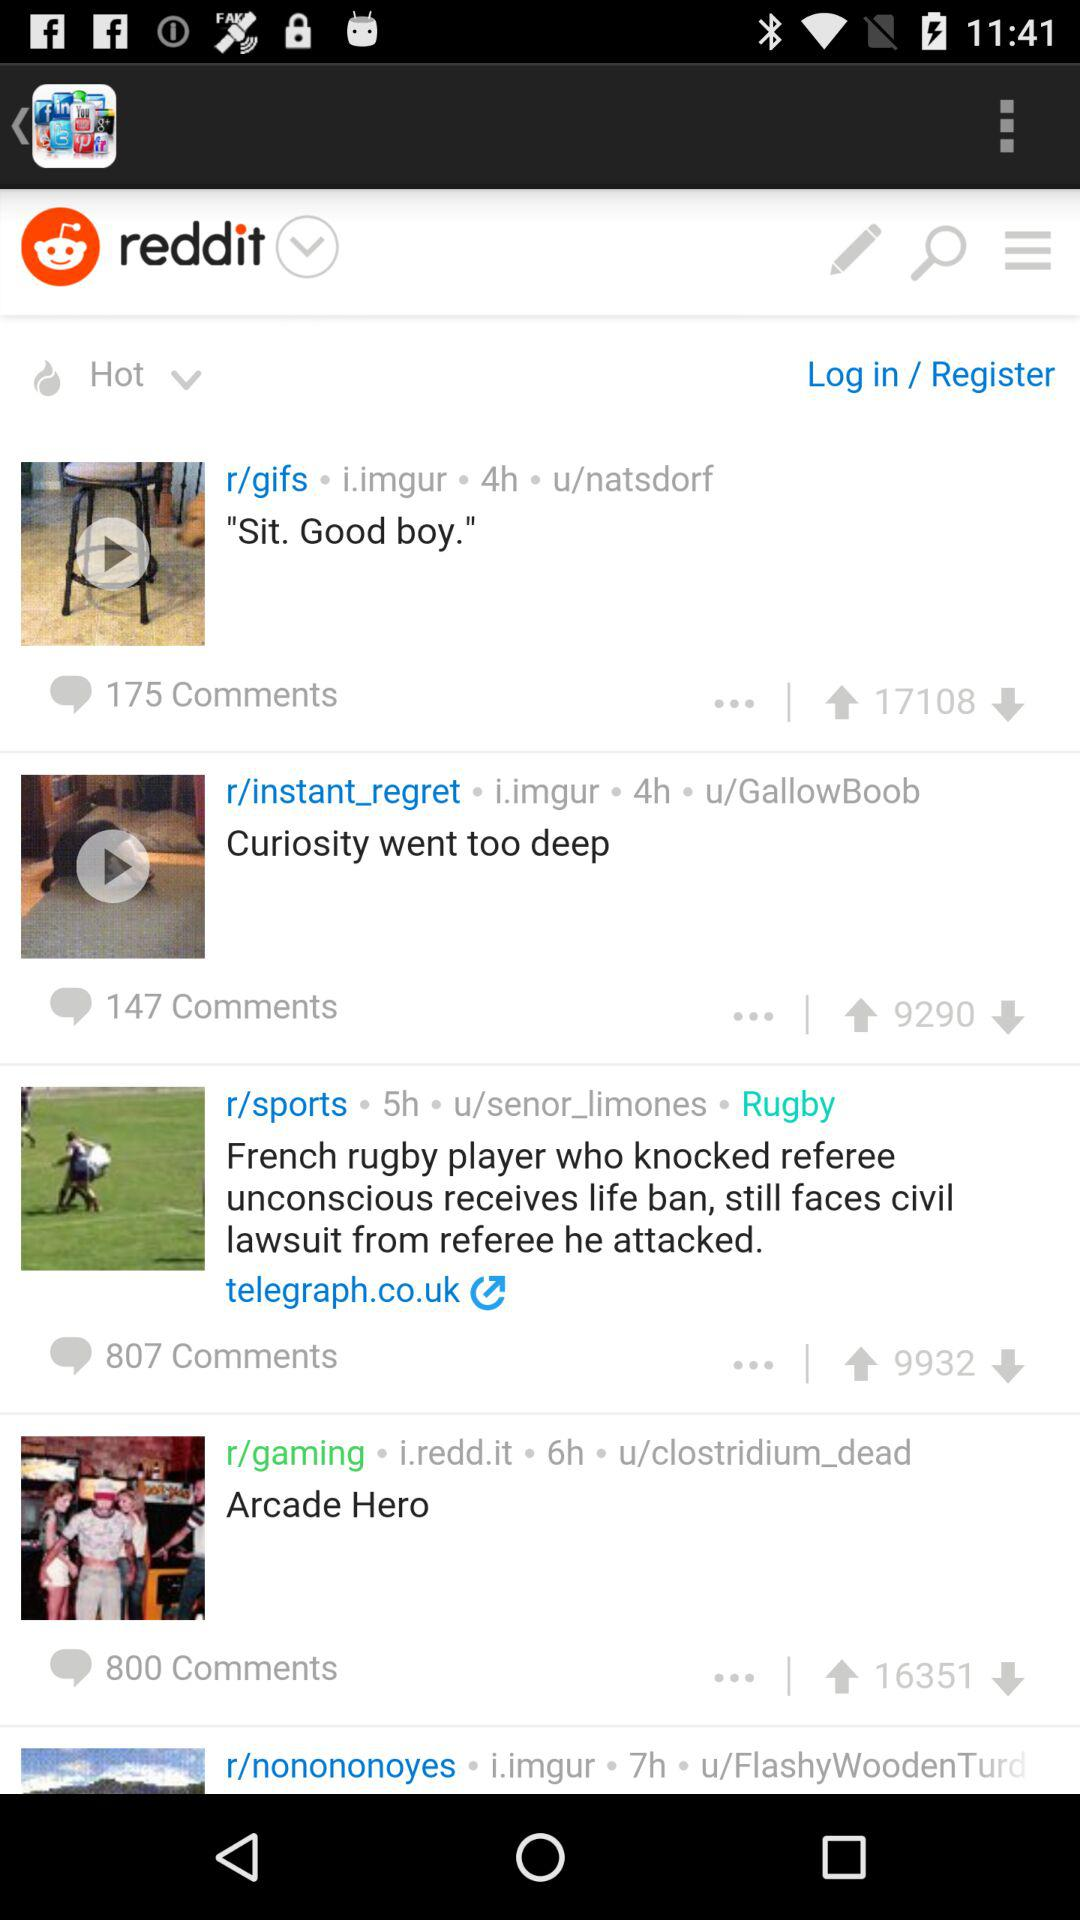What is the number of comments on "Curiosity went too deep"? The number of comments is 147. 